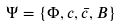Convert formula to latex. <formula><loc_0><loc_0><loc_500><loc_500>\Psi = \{ \Phi , c , \bar { c } , B \}</formula> 